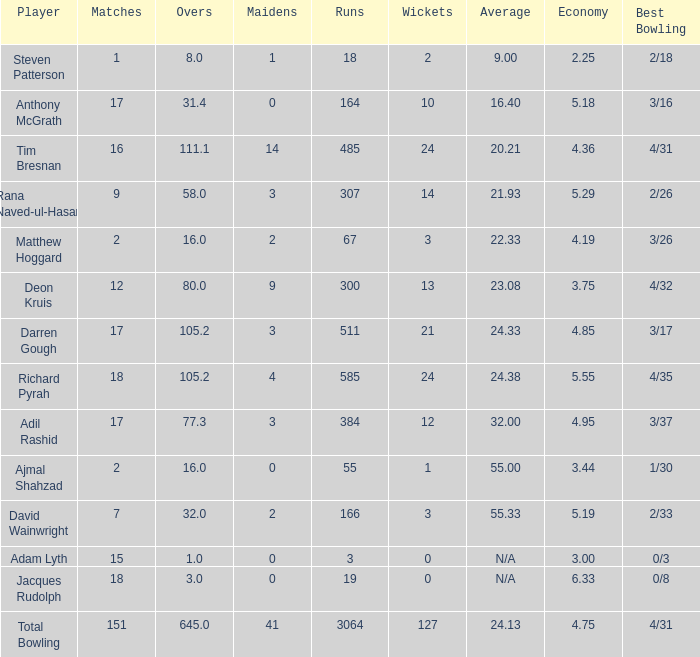What is the lowest Overs with a Run that is 18? 8.0. 